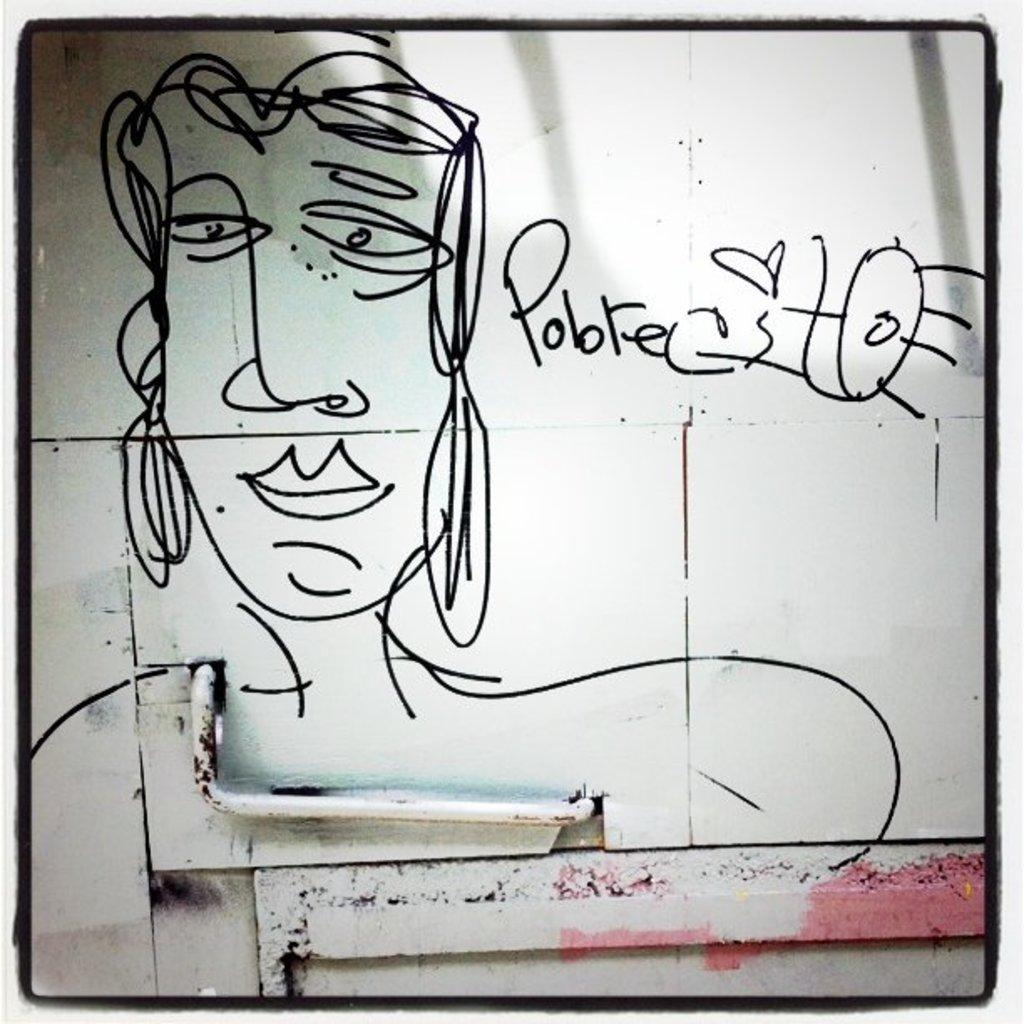What is present on the wall in the image? The wall has an art piece on it and text. Can you describe the art piece on the wall? Unfortunately, the specific details of the art piece cannot be determined from the provided facts. What else can be seen on the wall besides the art piece? There is text on the wall. What other object is visible in the image? There is a pipe in the image. What position does the wren hold in the image? There is no wren present in the image. How does the fog affect the visibility of the art piece on the wall? There is no fog present in the image, so its effect on the visibility of the art piece cannot be determined. 